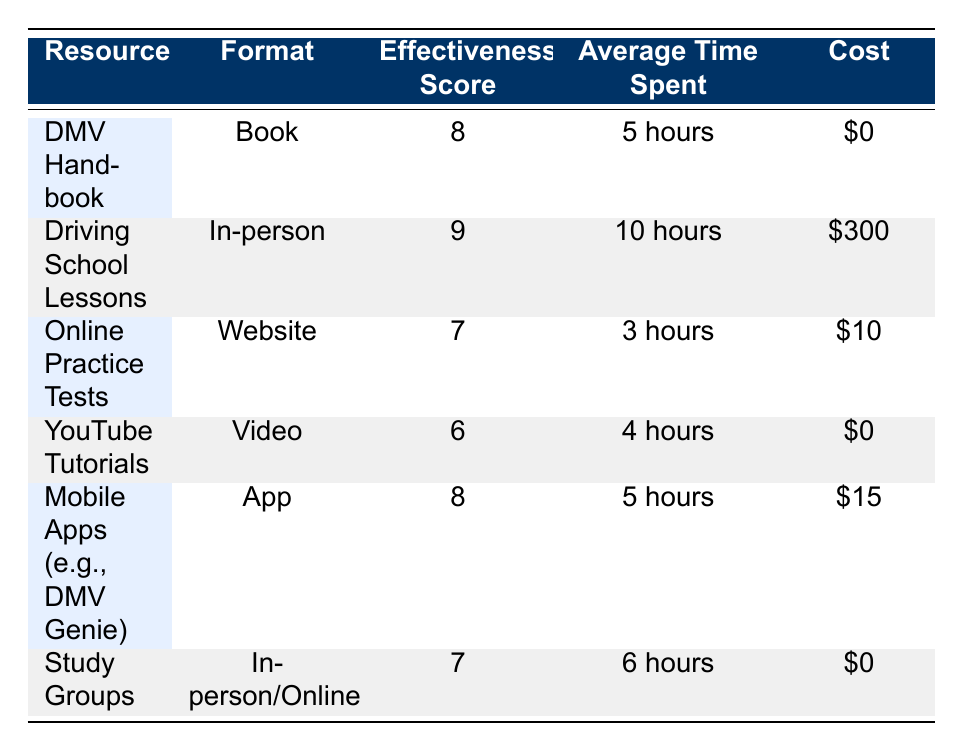What is the effectiveness score of Driving School Lessons? The effectiveness score for Driving School Lessons is listed in the table under the 'Effectiveness Score' column for that specific resource. It shows a score of 9.
Answer: 9 How much does it cost to use Online Practice Tests? The cost is presented in the table under the 'Cost' column for Online Practice Tests. It indicates that the cost is $10.
Answer: $10 Which resource has the highest effectiveness score? To find the resource with the highest effectiveness score, look through the 'Effectiveness Score' column and identify the maximum value. Driving School Lessons has the highest score of 9.
Answer: Driving School Lessons How much more time is typically spent on Driving School Lessons compared to YouTube Tutorials? The average time spent on Driving School Lessons is 10 hours, while for YouTube Tutorials it is 4 hours. To find the difference, subtract the time spent on YouTube Tutorials from that spent on Driving School Lessons: 10 hours - 4 hours = 6 hours.
Answer: 6 hours Is the DMV Handbook more effective than YouTube Tutorials? Comparing the effectiveness scores from the table shows that the DMV Handbook has a score of 8, while YouTube Tutorials has a score of 6. Since 8 is greater than 6, the answer is yes, the DMV Handbook is more effective.
Answer: Yes What is the average effectiveness score of all resources listed? To calculate the average effectiveness score, sum all the effectiveness scores: 8 + 9 + 7 + 6 + 8 + 7 = 45. There are 6 resources, so divide the total by 6: 45 / 6 = 7.5.
Answer: 7.5 Are Mobile Apps more expensive than Online Practice Tests? The cost of Mobile Apps is $15, and the cost of Online Practice Tests is $10. Since $15 is greater than $10, Mobile Apps are more expensive.
Answer: Yes What is the total average time spent across all resources? To find the total average time, convert all the time into hours and sum them: 5 + 10 + 3 + 4 + 5 + 6 = 33 hours. Then divide the total by the number of resources, which is 6: 33 / 6 = 5.5 hours.
Answer: 5.5 hours What type of resource has the lowest effectiveness score, and what is that score? The table shows that YouTube Tutorials have the lowest effectiveness score of 6. This can be determined by comparing all scores in the 'Effectiveness Score' column.
Answer: YouTube Tutorials with a score of 6 